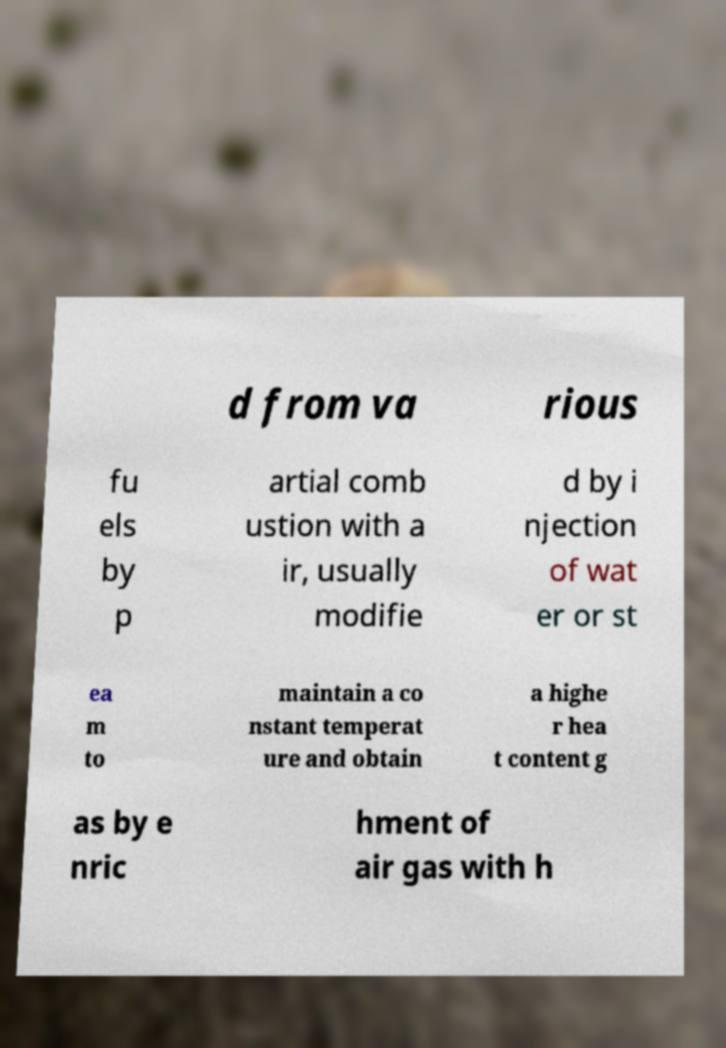Can you accurately transcribe the text from the provided image for me? d from va rious fu els by p artial comb ustion with a ir, usually modifie d by i njection of wat er or st ea m to maintain a co nstant temperat ure and obtain a highe r hea t content g as by e nric hment of air gas with h 